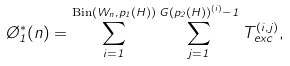<formula> <loc_0><loc_0><loc_500><loc_500>\chi _ { 1 } ^ { * } ( n ) = \sum _ { i = 1 } ^ { \text {Bin} ( W _ { n } , p _ { 1 } ( H ) ) } \sum _ { j = 1 } ^ { G ( p _ { 2 } ( H ) ) ^ { ( i ) } - 1 } T ^ { ( i , j ) } _ { e x c } ,</formula> 